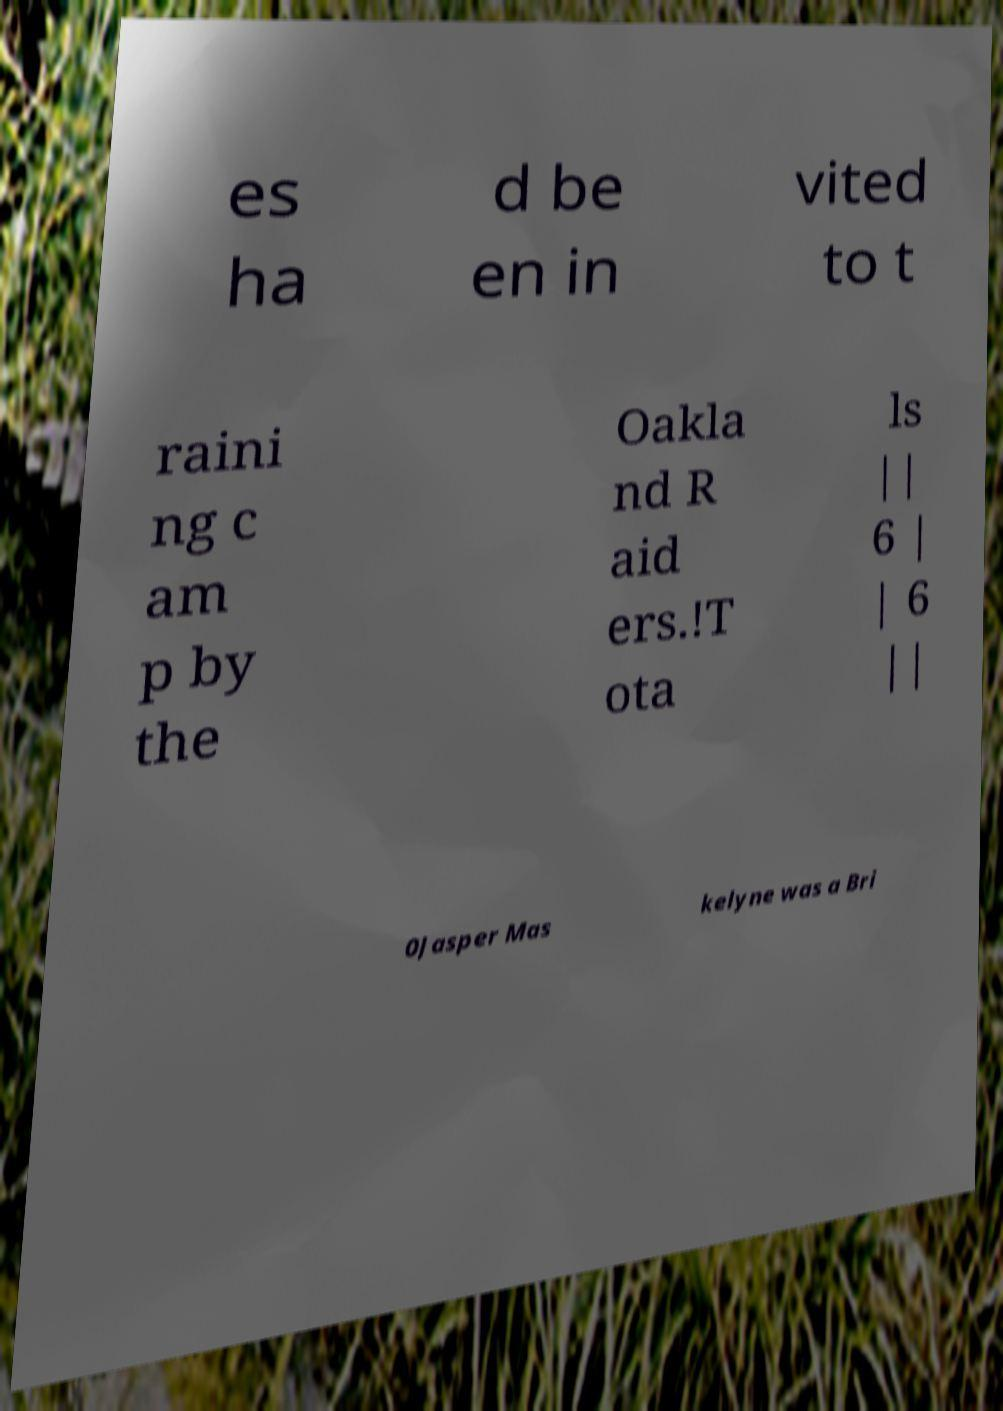What messages or text are displayed in this image? I need them in a readable, typed format. es ha d be en in vited to t raini ng c am p by the Oakla nd R aid ers.!T ota ls || 6 | | 6 || 0Jasper Mas kelyne was a Bri 